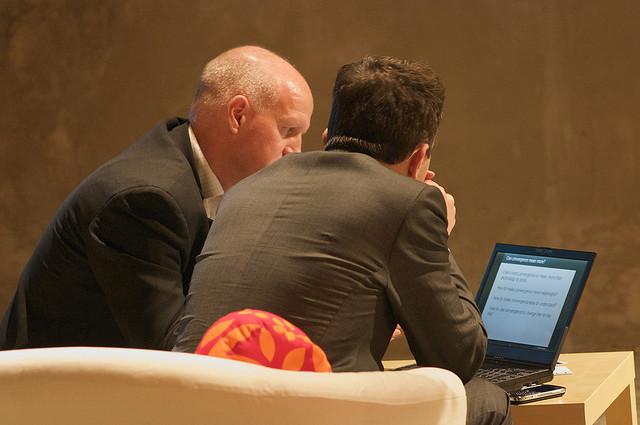Is the computer on?
Give a very brief answer. Yes. What are the men looking at?
Keep it brief. Laptop. Is there a cell phone?
Be succinct. Yes. 